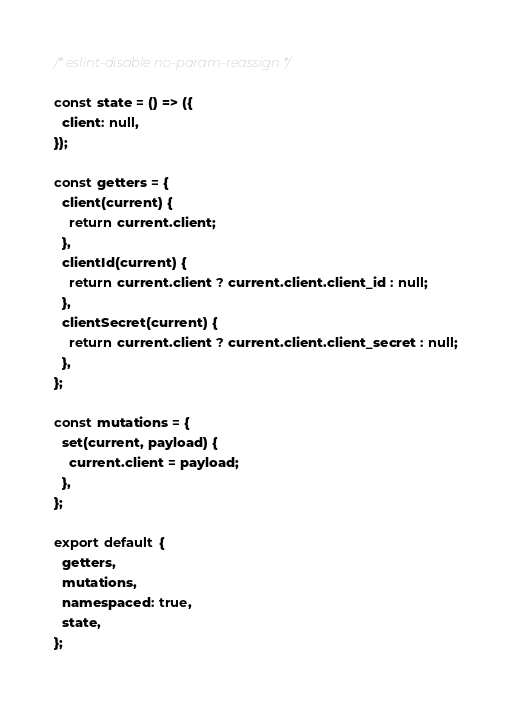Convert code to text. <code><loc_0><loc_0><loc_500><loc_500><_JavaScript_>/* eslint-disable no-param-reassign */

const state = () => ({
  client: null,
});

const getters = {
  client(current) {
    return current.client;
  },
  clientId(current) {
    return current.client ? current.client.client_id : null;
  },
  clientSecret(current) {
    return current.client ? current.client.client_secret : null;
  },
};

const mutations = {
  set(current, payload) {
    current.client = payload;
  },
};

export default {
  getters,
  mutations,
  namespaced: true,
  state,
};
</code> 